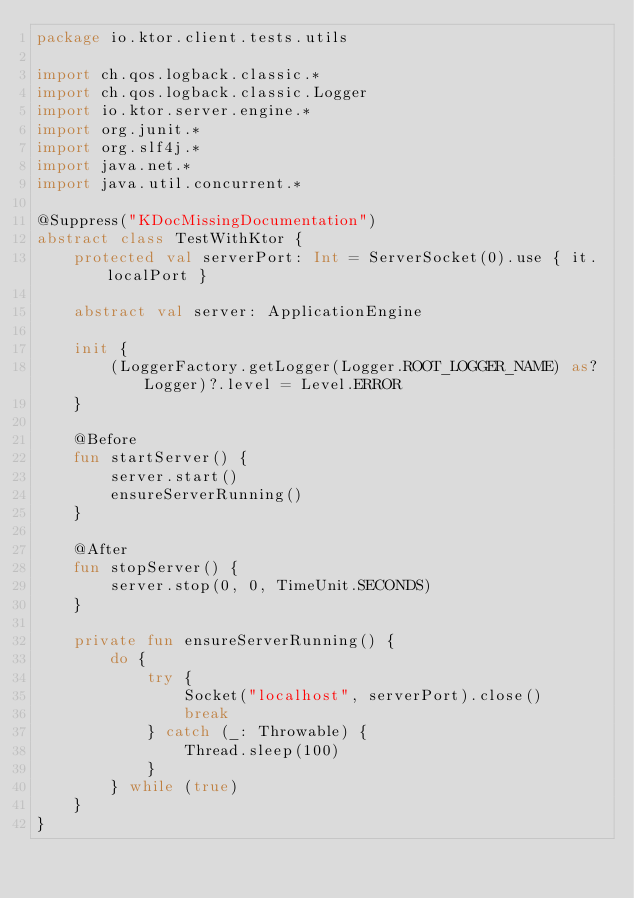<code> <loc_0><loc_0><loc_500><loc_500><_Kotlin_>package io.ktor.client.tests.utils

import ch.qos.logback.classic.*
import ch.qos.logback.classic.Logger
import io.ktor.server.engine.*
import org.junit.*
import org.slf4j.*
import java.net.*
import java.util.concurrent.*

@Suppress("KDocMissingDocumentation")
abstract class TestWithKtor {
    protected val serverPort: Int = ServerSocket(0).use { it.localPort }

    abstract val server: ApplicationEngine

    init {
        (LoggerFactory.getLogger(Logger.ROOT_LOGGER_NAME) as? Logger)?.level = Level.ERROR
    }

    @Before
    fun startServer() {
        server.start()
        ensureServerRunning()
    }

    @After
    fun stopServer() {
        server.stop(0, 0, TimeUnit.SECONDS)
    }

    private fun ensureServerRunning() {
        do {
            try {
                Socket("localhost", serverPort).close()
                break
            } catch (_: Throwable) {
                Thread.sleep(100)
            }
        } while (true)
    }
}
</code> 